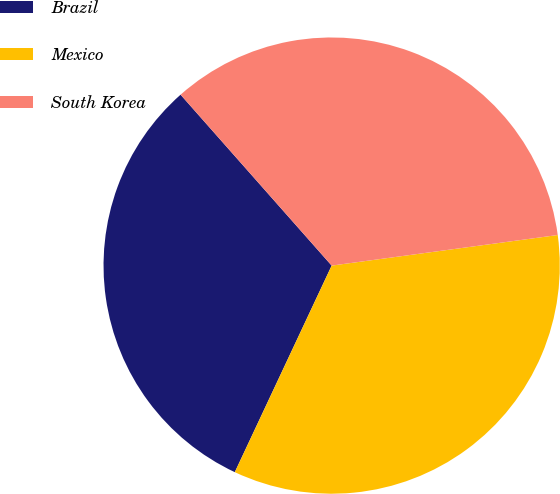<chart> <loc_0><loc_0><loc_500><loc_500><pie_chart><fcel>Brazil<fcel>Mexico<fcel>South Korea<nl><fcel>31.5%<fcel>34.12%<fcel>34.38%<nl></chart> 